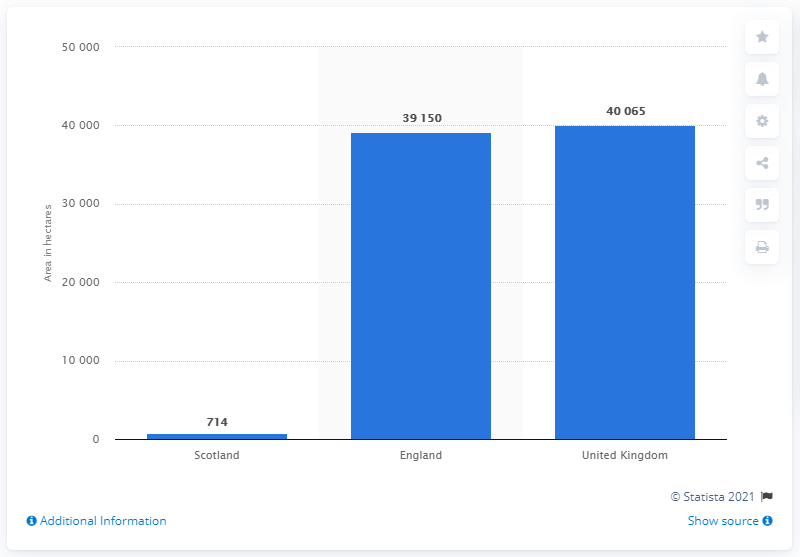Outline some significant characteristics in this image. The ratio between Scotland and England is approximately 0.0197. In June 2017, a total of 39,150 hectares of peas were grown in England. The region with the least area is Scotland. 